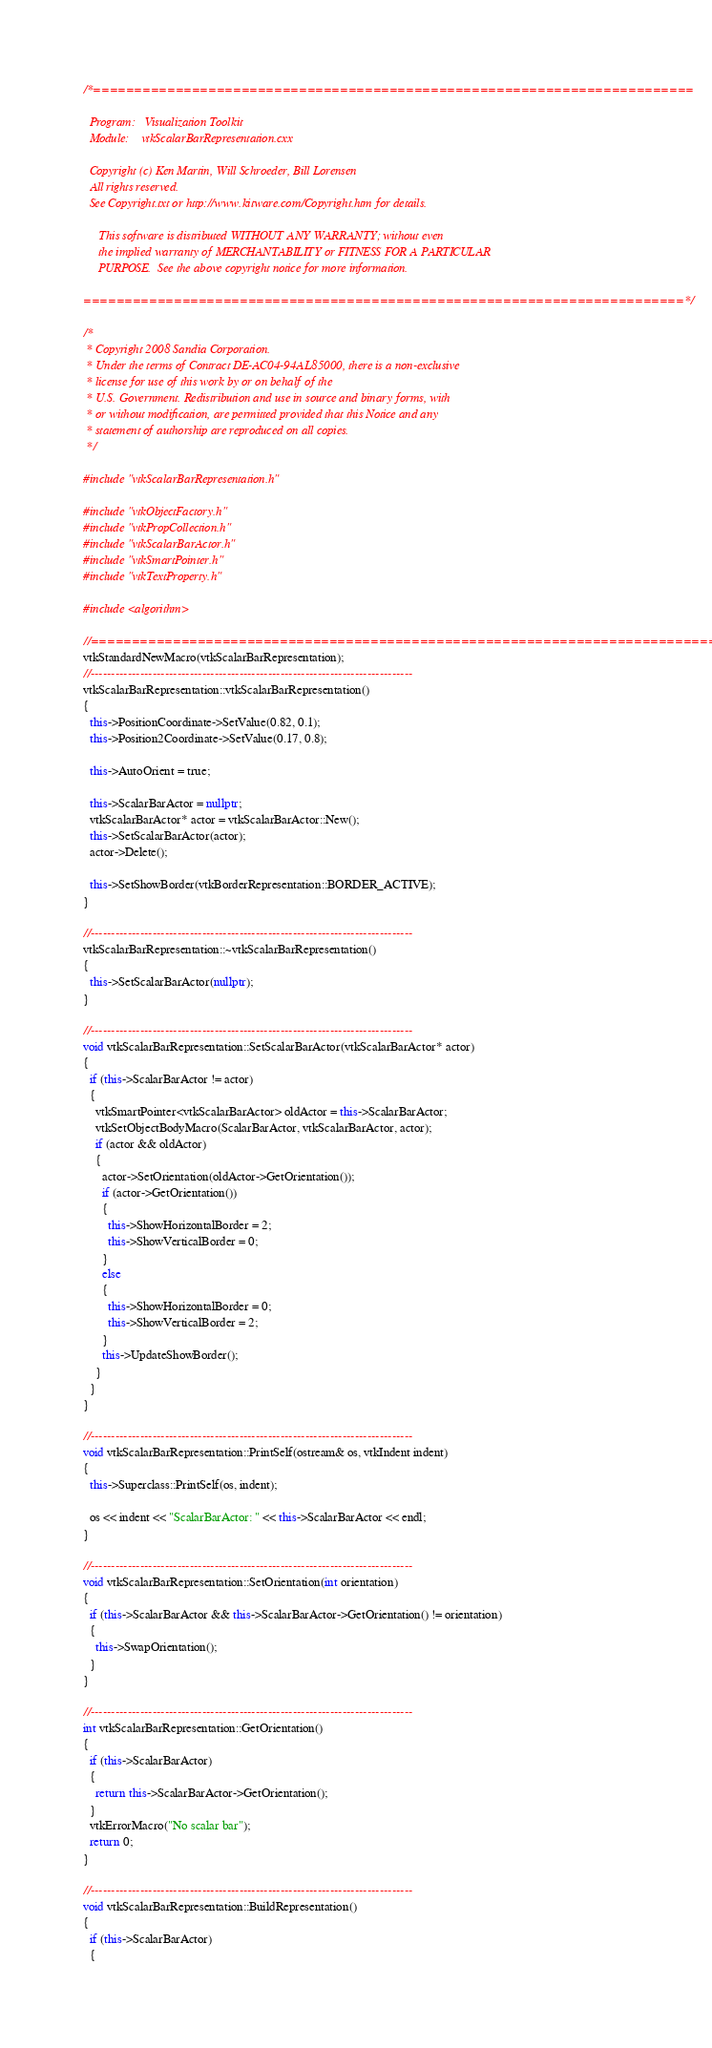<code> <loc_0><loc_0><loc_500><loc_500><_C++_>/*=========================================================================

  Program:   Visualization Toolkit
  Module:    vtkScalarBarRepresentation.cxx

  Copyright (c) Ken Martin, Will Schroeder, Bill Lorensen
  All rights reserved.
  See Copyright.txt or http://www.kitware.com/Copyright.htm for details.

     This software is distributed WITHOUT ANY WARRANTY; without even
     the implied warranty of MERCHANTABILITY or FITNESS FOR A PARTICULAR
     PURPOSE.  See the above copyright notice for more information.

=========================================================================*/

/*
 * Copyright 2008 Sandia Corporation.
 * Under the terms of Contract DE-AC04-94AL85000, there is a non-exclusive
 * license for use of this work by or on behalf of the
 * U.S. Government. Redistribution and use in source and binary forms, with
 * or without modification, are permitted provided that this Notice and any
 * statement of authorship are reproduced on all copies.
 */

#include "vtkScalarBarRepresentation.h"

#include "vtkObjectFactory.h"
#include "vtkPropCollection.h"
#include "vtkScalarBarActor.h"
#include "vtkSmartPointer.h"
#include "vtkTextProperty.h"

#include <algorithm>

//=============================================================================
vtkStandardNewMacro(vtkScalarBarRepresentation);
//------------------------------------------------------------------------------
vtkScalarBarRepresentation::vtkScalarBarRepresentation()
{
  this->PositionCoordinate->SetValue(0.82, 0.1);
  this->Position2Coordinate->SetValue(0.17, 0.8);

  this->AutoOrient = true;

  this->ScalarBarActor = nullptr;
  vtkScalarBarActor* actor = vtkScalarBarActor::New();
  this->SetScalarBarActor(actor);
  actor->Delete();

  this->SetShowBorder(vtkBorderRepresentation::BORDER_ACTIVE);
}

//------------------------------------------------------------------------------
vtkScalarBarRepresentation::~vtkScalarBarRepresentation()
{
  this->SetScalarBarActor(nullptr);
}

//------------------------------------------------------------------------------
void vtkScalarBarRepresentation::SetScalarBarActor(vtkScalarBarActor* actor)
{
  if (this->ScalarBarActor != actor)
  {
    vtkSmartPointer<vtkScalarBarActor> oldActor = this->ScalarBarActor;
    vtkSetObjectBodyMacro(ScalarBarActor, vtkScalarBarActor, actor);
    if (actor && oldActor)
    {
      actor->SetOrientation(oldActor->GetOrientation());
      if (actor->GetOrientation())
      {
        this->ShowHorizontalBorder = 2;
        this->ShowVerticalBorder = 0;
      }
      else
      {
        this->ShowHorizontalBorder = 0;
        this->ShowVerticalBorder = 2;
      }
      this->UpdateShowBorder();
    }
  }
}

//------------------------------------------------------------------------------
void vtkScalarBarRepresentation::PrintSelf(ostream& os, vtkIndent indent)
{
  this->Superclass::PrintSelf(os, indent);

  os << indent << "ScalarBarActor: " << this->ScalarBarActor << endl;
}

//------------------------------------------------------------------------------
void vtkScalarBarRepresentation::SetOrientation(int orientation)
{
  if (this->ScalarBarActor && this->ScalarBarActor->GetOrientation() != orientation)
  {
    this->SwapOrientation();
  }
}

//------------------------------------------------------------------------------
int vtkScalarBarRepresentation::GetOrientation()
{
  if (this->ScalarBarActor)
  {
    return this->ScalarBarActor->GetOrientation();
  }
  vtkErrorMacro("No scalar bar");
  return 0;
}

//------------------------------------------------------------------------------
void vtkScalarBarRepresentation::BuildRepresentation()
{
  if (this->ScalarBarActor)
  {</code> 